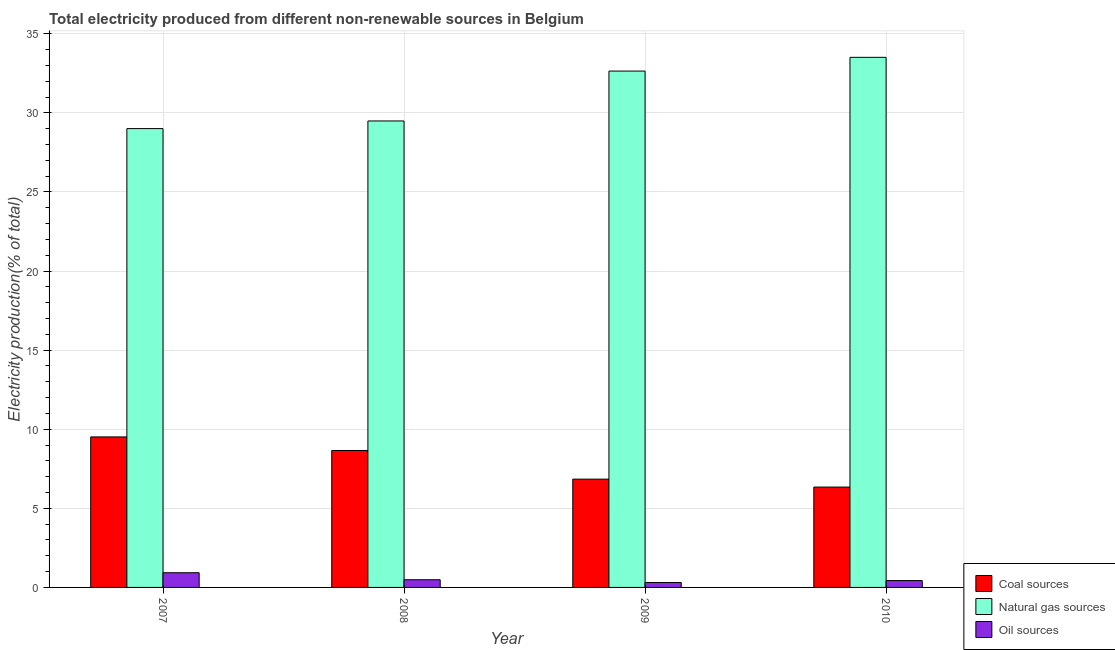How many groups of bars are there?
Your answer should be very brief. 4. Are the number of bars per tick equal to the number of legend labels?
Your response must be concise. Yes. How many bars are there on the 4th tick from the right?
Give a very brief answer. 3. What is the label of the 1st group of bars from the left?
Provide a succinct answer. 2007. In how many cases, is the number of bars for a given year not equal to the number of legend labels?
Your answer should be compact. 0. What is the percentage of electricity produced by natural gas in 2009?
Your response must be concise. 32.64. Across all years, what is the maximum percentage of electricity produced by coal?
Ensure brevity in your answer.  9.51. Across all years, what is the minimum percentage of electricity produced by coal?
Give a very brief answer. 6.34. In which year was the percentage of electricity produced by coal minimum?
Provide a succinct answer. 2010. What is the total percentage of electricity produced by natural gas in the graph?
Provide a succinct answer. 124.64. What is the difference between the percentage of electricity produced by natural gas in 2007 and that in 2008?
Your response must be concise. -0.48. What is the difference between the percentage of electricity produced by natural gas in 2008 and the percentage of electricity produced by coal in 2009?
Make the answer very short. -3.15. What is the average percentage of electricity produced by natural gas per year?
Provide a succinct answer. 31.16. What is the ratio of the percentage of electricity produced by natural gas in 2007 to that in 2010?
Provide a succinct answer. 0.87. Is the percentage of electricity produced by oil sources in 2007 less than that in 2008?
Offer a very short reply. No. Is the difference between the percentage of electricity produced by oil sources in 2008 and 2010 greater than the difference between the percentage of electricity produced by coal in 2008 and 2010?
Offer a very short reply. No. What is the difference between the highest and the second highest percentage of electricity produced by oil sources?
Your response must be concise. 0.44. What is the difference between the highest and the lowest percentage of electricity produced by natural gas?
Offer a terse response. 4.51. In how many years, is the percentage of electricity produced by natural gas greater than the average percentage of electricity produced by natural gas taken over all years?
Make the answer very short. 2. What does the 2nd bar from the left in 2009 represents?
Make the answer very short. Natural gas sources. What does the 3rd bar from the right in 2007 represents?
Provide a short and direct response. Coal sources. Is it the case that in every year, the sum of the percentage of electricity produced by coal and percentage of electricity produced by natural gas is greater than the percentage of electricity produced by oil sources?
Make the answer very short. Yes. Are all the bars in the graph horizontal?
Your answer should be very brief. No. How many years are there in the graph?
Your answer should be compact. 4. What is the difference between two consecutive major ticks on the Y-axis?
Keep it short and to the point. 5. How many legend labels are there?
Provide a succinct answer. 3. What is the title of the graph?
Ensure brevity in your answer.  Total electricity produced from different non-renewable sources in Belgium. Does "Solid fuel" appear as one of the legend labels in the graph?
Offer a terse response. No. What is the label or title of the X-axis?
Your answer should be compact. Year. What is the Electricity production(% of total) of Coal sources in 2007?
Your answer should be compact. 9.51. What is the Electricity production(% of total) in Natural gas sources in 2007?
Your answer should be compact. 29. What is the Electricity production(% of total) of Oil sources in 2007?
Ensure brevity in your answer.  0.93. What is the Electricity production(% of total) in Coal sources in 2008?
Keep it short and to the point. 8.66. What is the Electricity production(% of total) of Natural gas sources in 2008?
Ensure brevity in your answer.  29.49. What is the Electricity production(% of total) in Oil sources in 2008?
Provide a short and direct response. 0.49. What is the Electricity production(% of total) of Coal sources in 2009?
Offer a very short reply. 6.85. What is the Electricity production(% of total) in Natural gas sources in 2009?
Ensure brevity in your answer.  32.64. What is the Electricity production(% of total) of Oil sources in 2009?
Provide a short and direct response. 0.31. What is the Electricity production(% of total) of Coal sources in 2010?
Keep it short and to the point. 6.34. What is the Electricity production(% of total) of Natural gas sources in 2010?
Offer a terse response. 33.51. What is the Electricity production(% of total) in Oil sources in 2010?
Offer a terse response. 0.43. Across all years, what is the maximum Electricity production(% of total) of Coal sources?
Ensure brevity in your answer.  9.51. Across all years, what is the maximum Electricity production(% of total) in Natural gas sources?
Your answer should be very brief. 33.51. Across all years, what is the maximum Electricity production(% of total) in Oil sources?
Provide a succinct answer. 0.93. Across all years, what is the minimum Electricity production(% of total) of Coal sources?
Give a very brief answer. 6.34. Across all years, what is the minimum Electricity production(% of total) of Natural gas sources?
Ensure brevity in your answer.  29. Across all years, what is the minimum Electricity production(% of total) in Oil sources?
Provide a short and direct response. 0.31. What is the total Electricity production(% of total) in Coal sources in the graph?
Ensure brevity in your answer.  31.36. What is the total Electricity production(% of total) of Natural gas sources in the graph?
Your answer should be very brief. 124.64. What is the total Electricity production(% of total) of Oil sources in the graph?
Provide a short and direct response. 2.16. What is the difference between the Electricity production(% of total) of Coal sources in 2007 and that in 2008?
Give a very brief answer. 0.86. What is the difference between the Electricity production(% of total) of Natural gas sources in 2007 and that in 2008?
Your response must be concise. -0.48. What is the difference between the Electricity production(% of total) of Oil sources in 2007 and that in 2008?
Your answer should be very brief. 0.44. What is the difference between the Electricity production(% of total) of Coal sources in 2007 and that in 2009?
Your answer should be compact. 2.67. What is the difference between the Electricity production(% of total) of Natural gas sources in 2007 and that in 2009?
Your answer should be compact. -3.64. What is the difference between the Electricity production(% of total) in Oil sources in 2007 and that in 2009?
Your response must be concise. 0.62. What is the difference between the Electricity production(% of total) of Coal sources in 2007 and that in 2010?
Your answer should be compact. 3.17. What is the difference between the Electricity production(% of total) of Natural gas sources in 2007 and that in 2010?
Provide a short and direct response. -4.51. What is the difference between the Electricity production(% of total) of Oil sources in 2007 and that in 2010?
Ensure brevity in your answer.  0.5. What is the difference between the Electricity production(% of total) of Coal sources in 2008 and that in 2009?
Your response must be concise. 1.81. What is the difference between the Electricity production(% of total) in Natural gas sources in 2008 and that in 2009?
Your response must be concise. -3.15. What is the difference between the Electricity production(% of total) of Oil sources in 2008 and that in 2009?
Offer a very short reply. 0.17. What is the difference between the Electricity production(% of total) of Coal sources in 2008 and that in 2010?
Make the answer very short. 2.31. What is the difference between the Electricity production(% of total) of Natural gas sources in 2008 and that in 2010?
Ensure brevity in your answer.  -4.02. What is the difference between the Electricity production(% of total) in Oil sources in 2008 and that in 2010?
Give a very brief answer. 0.05. What is the difference between the Electricity production(% of total) of Coal sources in 2009 and that in 2010?
Give a very brief answer. 0.5. What is the difference between the Electricity production(% of total) of Natural gas sources in 2009 and that in 2010?
Offer a very short reply. -0.87. What is the difference between the Electricity production(% of total) in Oil sources in 2009 and that in 2010?
Give a very brief answer. -0.12. What is the difference between the Electricity production(% of total) in Coal sources in 2007 and the Electricity production(% of total) in Natural gas sources in 2008?
Ensure brevity in your answer.  -19.97. What is the difference between the Electricity production(% of total) in Coal sources in 2007 and the Electricity production(% of total) in Oil sources in 2008?
Offer a terse response. 9.03. What is the difference between the Electricity production(% of total) of Natural gas sources in 2007 and the Electricity production(% of total) of Oil sources in 2008?
Ensure brevity in your answer.  28.52. What is the difference between the Electricity production(% of total) in Coal sources in 2007 and the Electricity production(% of total) in Natural gas sources in 2009?
Your answer should be very brief. -23.13. What is the difference between the Electricity production(% of total) in Coal sources in 2007 and the Electricity production(% of total) in Oil sources in 2009?
Provide a succinct answer. 9.2. What is the difference between the Electricity production(% of total) of Natural gas sources in 2007 and the Electricity production(% of total) of Oil sources in 2009?
Ensure brevity in your answer.  28.69. What is the difference between the Electricity production(% of total) in Coal sources in 2007 and the Electricity production(% of total) in Natural gas sources in 2010?
Give a very brief answer. -24. What is the difference between the Electricity production(% of total) in Coal sources in 2007 and the Electricity production(% of total) in Oil sources in 2010?
Give a very brief answer. 9.08. What is the difference between the Electricity production(% of total) of Natural gas sources in 2007 and the Electricity production(% of total) of Oil sources in 2010?
Provide a short and direct response. 28.57. What is the difference between the Electricity production(% of total) of Coal sources in 2008 and the Electricity production(% of total) of Natural gas sources in 2009?
Give a very brief answer. -23.98. What is the difference between the Electricity production(% of total) in Coal sources in 2008 and the Electricity production(% of total) in Oil sources in 2009?
Your answer should be compact. 8.34. What is the difference between the Electricity production(% of total) in Natural gas sources in 2008 and the Electricity production(% of total) in Oil sources in 2009?
Keep it short and to the point. 29.18. What is the difference between the Electricity production(% of total) of Coal sources in 2008 and the Electricity production(% of total) of Natural gas sources in 2010?
Give a very brief answer. -24.85. What is the difference between the Electricity production(% of total) in Coal sources in 2008 and the Electricity production(% of total) in Oil sources in 2010?
Ensure brevity in your answer.  8.22. What is the difference between the Electricity production(% of total) of Natural gas sources in 2008 and the Electricity production(% of total) of Oil sources in 2010?
Your answer should be compact. 29.05. What is the difference between the Electricity production(% of total) of Coal sources in 2009 and the Electricity production(% of total) of Natural gas sources in 2010?
Your answer should be very brief. -26.66. What is the difference between the Electricity production(% of total) of Coal sources in 2009 and the Electricity production(% of total) of Oil sources in 2010?
Provide a short and direct response. 6.41. What is the difference between the Electricity production(% of total) of Natural gas sources in 2009 and the Electricity production(% of total) of Oil sources in 2010?
Offer a very short reply. 32.21. What is the average Electricity production(% of total) of Coal sources per year?
Make the answer very short. 7.84. What is the average Electricity production(% of total) in Natural gas sources per year?
Make the answer very short. 31.16. What is the average Electricity production(% of total) in Oil sources per year?
Provide a short and direct response. 0.54. In the year 2007, what is the difference between the Electricity production(% of total) of Coal sources and Electricity production(% of total) of Natural gas sources?
Ensure brevity in your answer.  -19.49. In the year 2007, what is the difference between the Electricity production(% of total) of Coal sources and Electricity production(% of total) of Oil sources?
Give a very brief answer. 8.58. In the year 2007, what is the difference between the Electricity production(% of total) of Natural gas sources and Electricity production(% of total) of Oil sources?
Your answer should be very brief. 28.08. In the year 2008, what is the difference between the Electricity production(% of total) of Coal sources and Electricity production(% of total) of Natural gas sources?
Offer a very short reply. -20.83. In the year 2008, what is the difference between the Electricity production(% of total) of Coal sources and Electricity production(% of total) of Oil sources?
Keep it short and to the point. 8.17. In the year 2008, what is the difference between the Electricity production(% of total) of Natural gas sources and Electricity production(% of total) of Oil sources?
Your answer should be compact. 29. In the year 2009, what is the difference between the Electricity production(% of total) of Coal sources and Electricity production(% of total) of Natural gas sources?
Offer a very short reply. -25.8. In the year 2009, what is the difference between the Electricity production(% of total) of Coal sources and Electricity production(% of total) of Oil sources?
Make the answer very short. 6.53. In the year 2009, what is the difference between the Electricity production(% of total) in Natural gas sources and Electricity production(% of total) in Oil sources?
Provide a succinct answer. 32.33. In the year 2010, what is the difference between the Electricity production(% of total) in Coal sources and Electricity production(% of total) in Natural gas sources?
Your answer should be compact. -27.17. In the year 2010, what is the difference between the Electricity production(% of total) in Coal sources and Electricity production(% of total) in Oil sources?
Provide a succinct answer. 5.91. In the year 2010, what is the difference between the Electricity production(% of total) in Natural gas sources and Electricity production(% of total) in Oil sources?
Provide a short and direct response. 33.08. What is the ratio of the Electricity production(% of total) of Coal sources in 2007 to that in 2008?
Your answer should be very brief. 1.1. What is the ratio of the Electricity production(% of total) of Natural gas sources in 2007 to that in 2008?
Ensure brevity in your answer.  0.98. What is the ratio of the Electricity production(% of total) of Oil sources in 2007 to that in 2008?
Offer a terse response. 1.91. What is the ratio of the Electricity production(% of total) of Coal sources in 2007 to that in 2009?
Keep it short and to the point. 1.39. What is the ratio of the Electricity production(% of total) in Natural gas sources in 2007 to that in 2009?
Ensure brevity in your answer.  0.89. What is the ratio of the Electricity production(% of total) of Oil sources in 2007 to that in 2009?
Your answer should be very brief. 2.98. What is the ratio of the Electricity production(% of total) in Coal sources in 2007 to that in 2010?
Make the answer very short. 1.5. What is the ratio of the Electricity production(% of total) of Natural gas sources in 2007 to that in 2010?
Offer a very short reply. 0.87. What is the ratio of the Electricity production(% of total) in Oil sources in 2007 to that in 2010?
Offer a very short reply. 2.15. What is the ratio of the Electricity production(% of total) of Coal sources in 2008 to that in 2009?
Provide a short and direct response. 1.26. What is the ratio of the Electricity production(% of total) of Natural gas sources in 2008 to that in 2009?
Offer a terse response. 0.9. What is the ratio of the Electricity production(% of total) in Oil sources in 2008 to that in 2009?
Offer a terse response. 1.56. What is the ratio of the Electricity production(% of total) in Coal sources in 2008 to that in 2010?
Your answer should be compact. 1.36. What is the ratio of the Electricity production(% of total) in Oil sources in 2008 to that in 2010?
Offer a very short reply. 1.12. What is the ratio of the Electricity production(% of total) of Coal sources in 2009 to that in 2010?
Provide a succinct answer. 1.08. What is the ratio of the Electricity production(% of total) of Natural gas sources in 2009 to that in 2010?
Offer a terse response. 0.97. What is the ratio of the Electricity production(% of total) in Oil sources in 2009 to that in 2010?
Make the answer very short. 0.72. What is the difference between the highest and the second highest Electricity production(% of total) in Coal sources?
Keep it short and to the point. 0.86. What is the difference between the highest and the second highest Electricity production(% of total) of Natural gas sources?
Ensure brevity in your answer.  0.87. What is the difference between the highest and the second highest Electricity production(% of total) of Oil sources?
Your response must be concise. 0.44. What is the difference between the highest and the lowest Electricity production(% of total) of Coal sources?
Give a very brief answer. 3.17. What is the difference between the highest and the lowest Electricity production(% of total) of Natural gas sources?
Keep it short and to the point. 4.51. What is the difference between the highest and the lowest Electricity production(% of total) in Oil sources?
Your response must be concise. 0.62. 